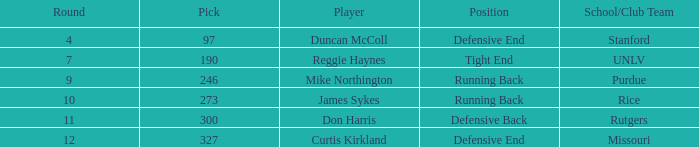What is the complete sum of rounds with draft pick 97, duncan mccoll? 0.0. 